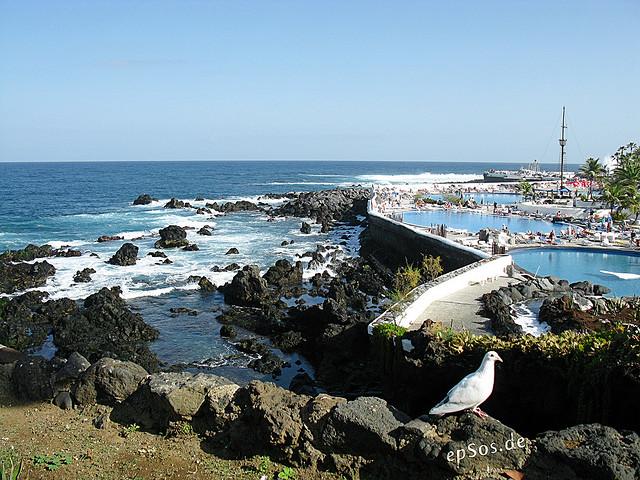Where is the photo taken?
Quick response, please. Island. How many boats are there?
Keep it brief. 2. What sticks out the water?
Keep it brief. Rocks. Is that a seabird?
Short answer required. Yes. 